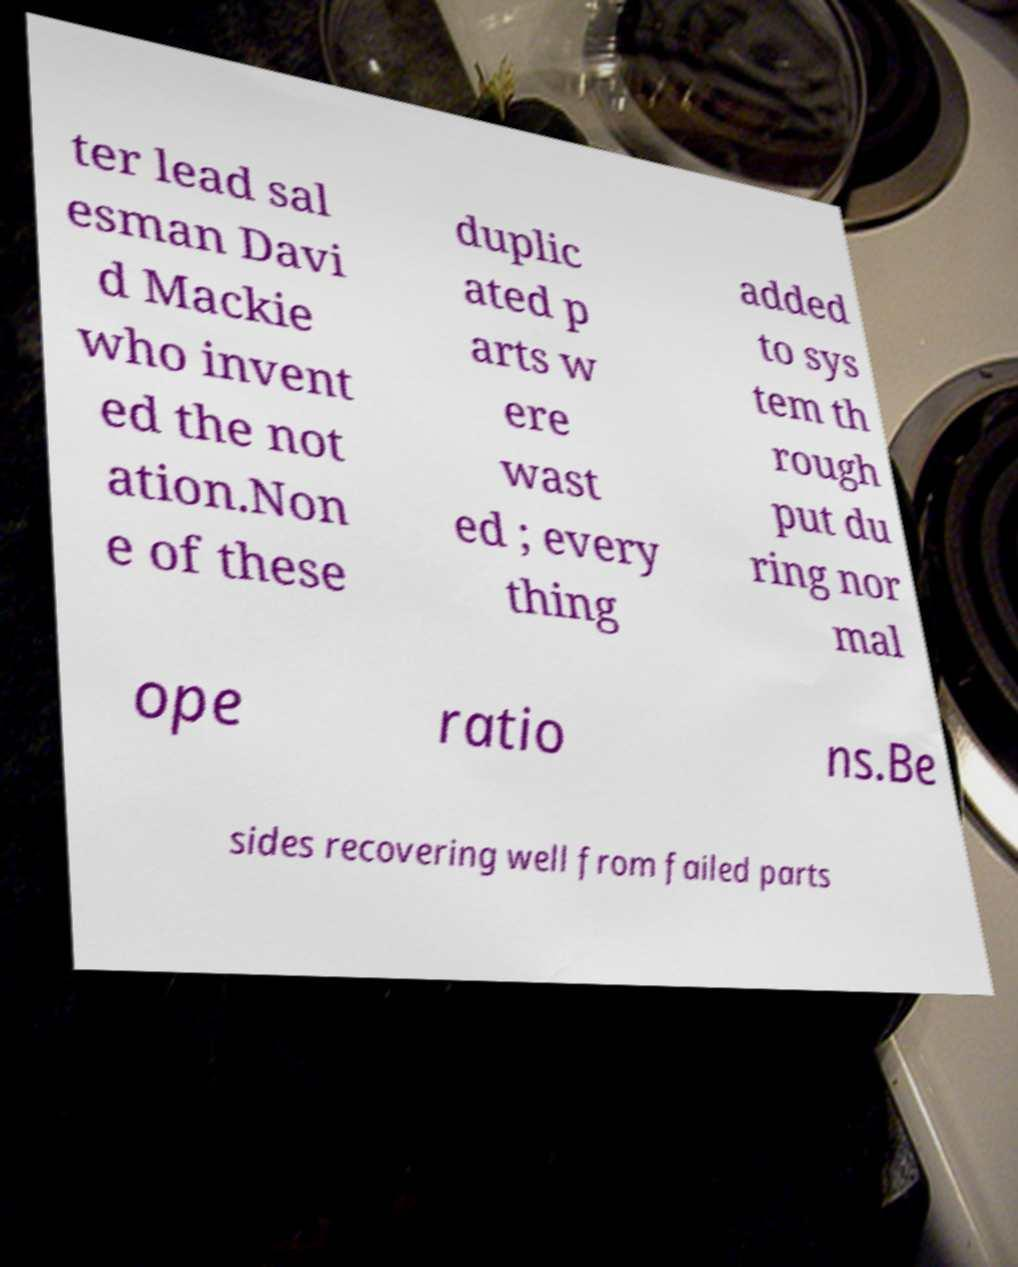Can you accurately transcribe the text from the provided image for me? ter lead sal esman Davi d Mackie who invent ed the not ation.Non e of these duplic ated p arts w ere wast ed ; every thing added to sys tem th rough put du ring nor mal ope ratio ns.Be sides recovering well from failed parts 